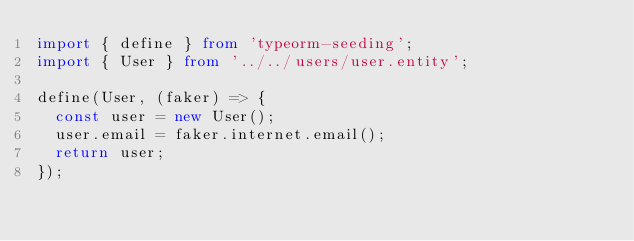Convert code to text. <code><loc_0><loc_0><loc_500><loc_500><_TypeScript_>import { define } from 'typeorm-seeding';
import { User } from '../../users/user.entity';

define(User, (faker) => {
  const user = new User();
  user.email = faker.internet.email();
  return user;
});
</code> 